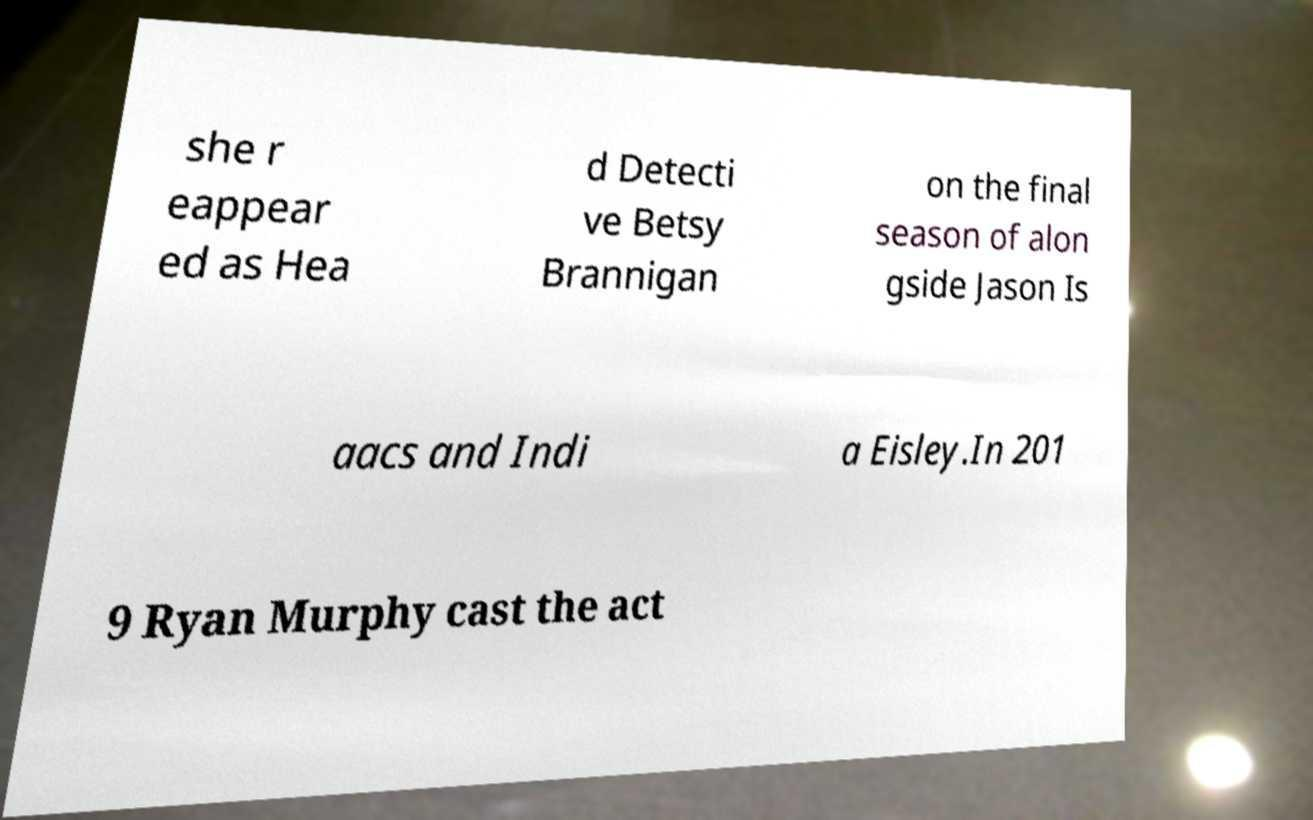Could you assist in decoding the text presented in this image and type it out clearly? she r eappear ed as Hea d Detecti ve Betsy Brannigan on the final season of alon gside Jason Is aacs and Indi a Eisley.In 201 9 Ryan Murphy cast the act 